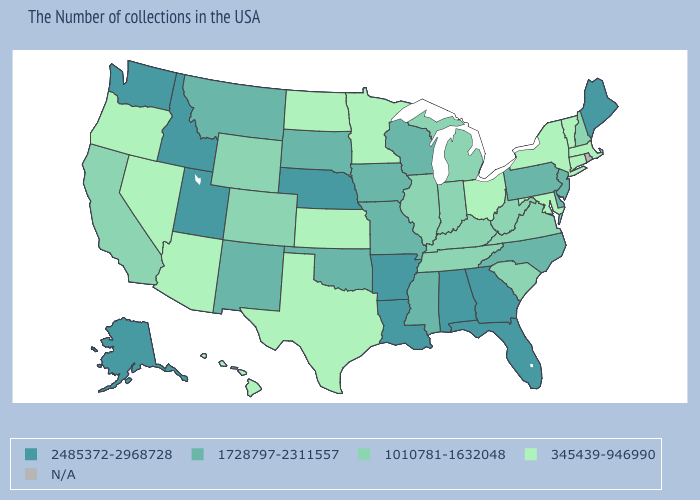Among the states that border Wyoming , does Nebraska have the highest value?
Answer briefly. Yes. Is the legend a continuous bar?
Concise answer only. No. Among the states that border North Carolina , which have the lowest value?
Write a very short answer. Virginia, South Carolina, Tennessee. Name the states that have a value in the range 2485372-2968728?
Quick response, please. Maine, Florida, Georgia, Alabama, Louisiana, Arkansas, Nebraska, Utah, Idaho, Washington, Alaska. Which states have the lowest value in the West?
Keep it brief. Arizona, Nevada, Oregon, Hawaii. What is the value of Maryland?
Answer briefly. 345439-946990. Name the states that have a value in the range 2485372-2968728?
Keep it brief. Maine, Florida, Georgia, Alabama, Louisiana, Arkansas, Nebraska, Utah, Idaho, Washington, Alaska. What is the value of Vermont?
Answer briefly. 345439-946990. What is the highest value in states that border Maryland?
Short answer required. 1728797-2311557. Among the states that border North Dakota , does South Dakota have the lowest value?
Be succinct. No. Does the first symbol in the legend represent the smallest category?
Quick response, please. No. Name the states that have a value in the range 345439-946990?
Quick response, please. Massachusetts, Vermont, Connecticut, New York, Maryland, Ohio, Minnesota, Kansas, Texas, North Dakota, Arizona, Nevada, Oregon, Hawaii. How many symbols are there in the legend?
Quick response, please. 5. 